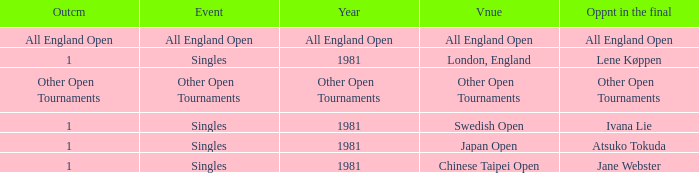What is the Opponent in final with an All England Open Outcome? All England Open. 